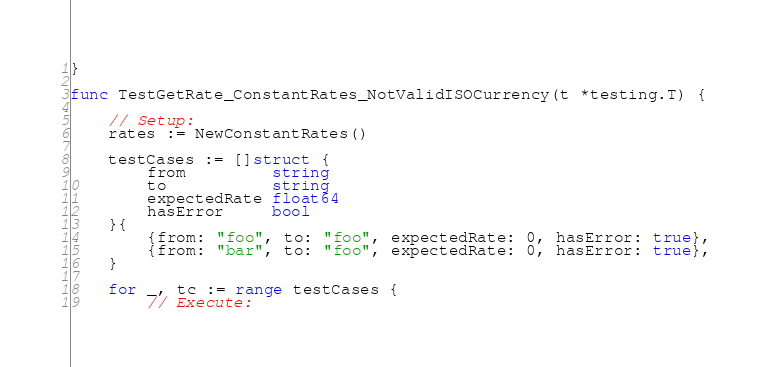<code> <loc_0><loc_0><loc_500><loc_500><_Go_>}

func TestGetRate_ConstantRates_NotValidISOCurrency(t *testing.T) {

	// Setup:
	rates := NewConstantRates()

	testCases := []struct {
		from         string
		to           string
		expectedRate float64
		hasError     bool
	}{
		{from: "foo", to: "foo", expectedRate: 0, hasError: true},
		{from: "bar", to: "foo", expectedRate: 0, hasError: true},
	}

	for _, tc := range testCases {
		// Execute:</code> 